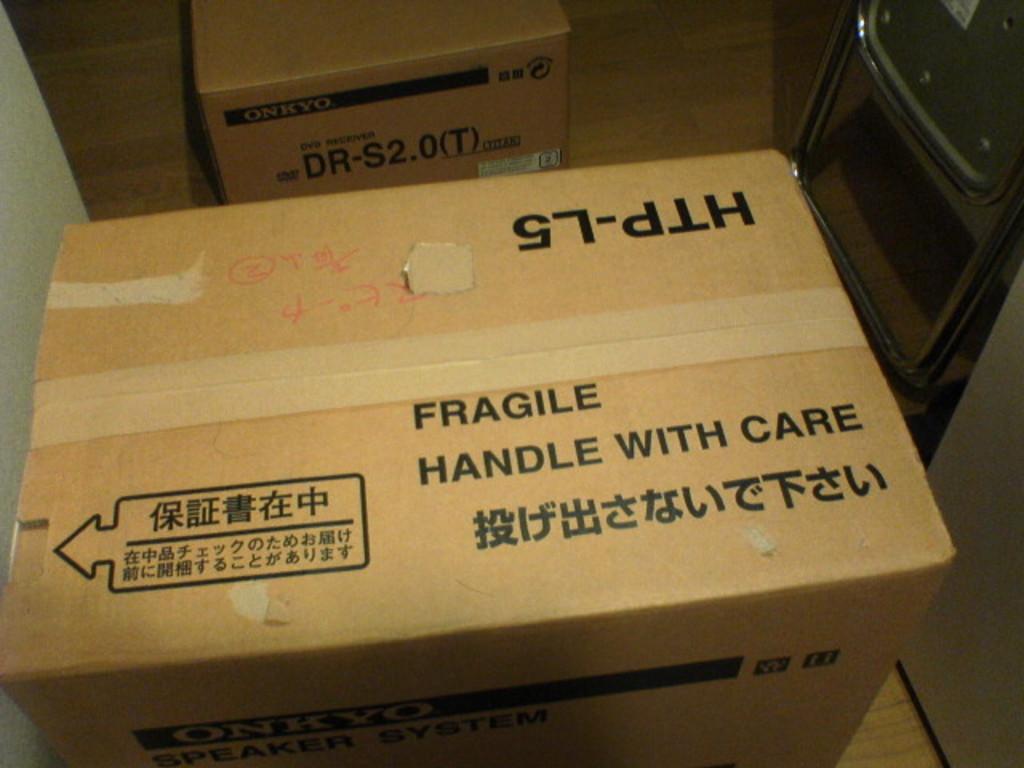What is in the box?
Your response must be concise. Unanswerable. Handle with what?
Offer a terse response. Care. 